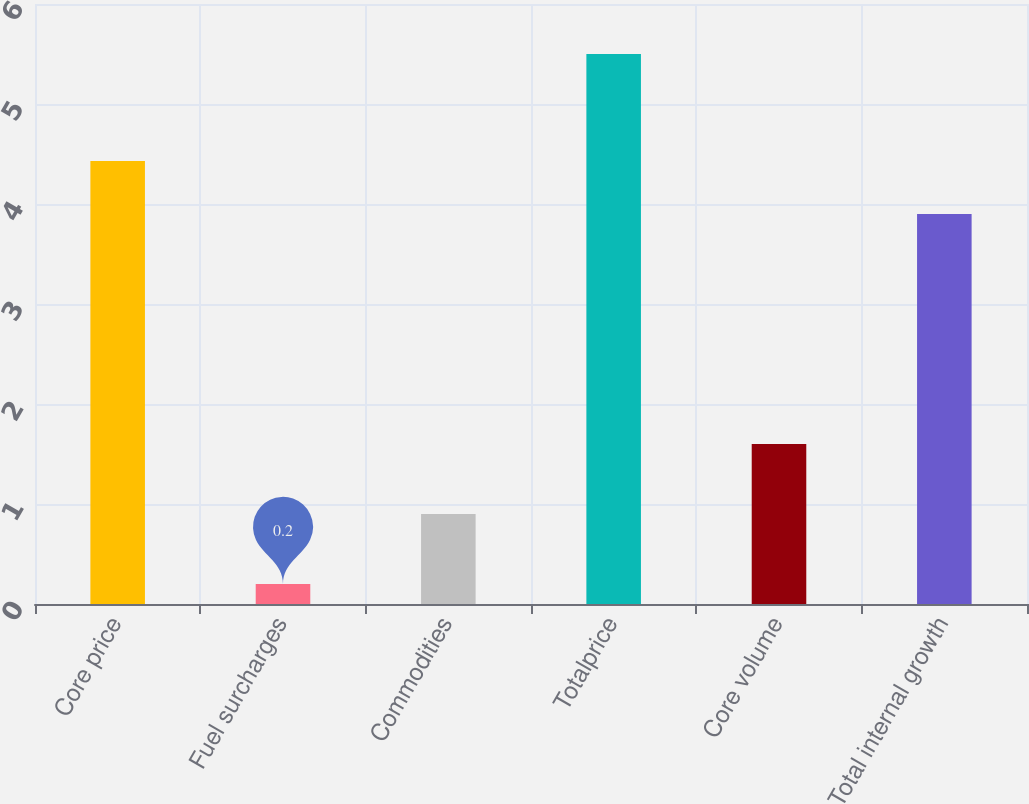Convert chart to OTSL. <chart><loc_0><loc_0><loc_500><loc_500><bar_chart><fcel>Core price<fcel>Fuel surcharges<fcel>Commodities<fcel>Totalprice<fcel>Core volume<fcel>Total internal growth<nl><fcel>4.43<fcel>0.2<fcel>0.9<fcel>5.5<fcel>1.6<fcel>3.9<nl></chart> 